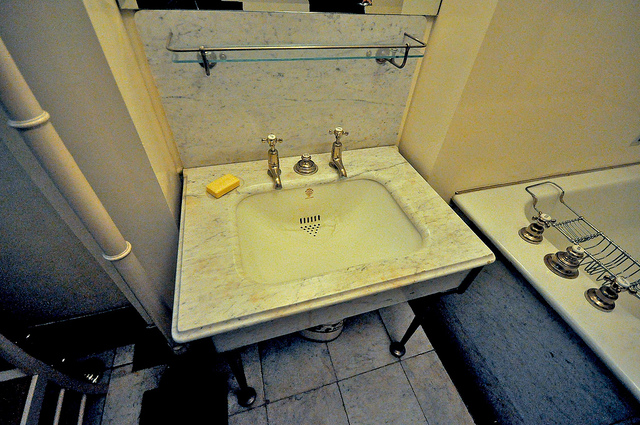What can you tell me about the design style of this bathroom? The bathroom exhibits a classic and elegant design style, characterized by the use of marble for the sink countertop and clean, minimalist fixtures. The metal fixtures have a traditional look that complements the marble. This blend of materials and the overall layout suggest a timeless aesthetic, combining both functionality and sophistication. Can you imagine a narrative set in this bathroom? Describe a scene in detail. In the early morning light, the bathroom glows softly with the first rays of the sun peeking through a frosted window. The marble countertop gleams with a subtle sheen, reflecting the day's burgeoning light. A woman, dressed in a plush robe, approaches the sink and places her coffee cup down on the marble surface. The aroma of freshly brewed coffee fills the room, mingling with the hint of lavender from a nearby diffuser.
She turns on the left-hand faucet, cold water cascading into the pristine white basin. She splashes her face, droplets glistening like dew on her skin. She reaches for the yellow soap, its lemon scent invigorating her senses. The room is serene, a sanctuary from the hustle and bustle of the morning rush. Every element is carefully curated to offer a moment of peace and luxury.
Nearby, a delicate plant adds a touch of greenery, its leaves rustling gently as if whispering secrets of tranquility. The woman looks into the mirror, taking a moment to gather her thoughts before starting her day. The bathroom, with its classical elegance, serves as a reminder that beauty and grace can be found in the simplest of daily rituals. 